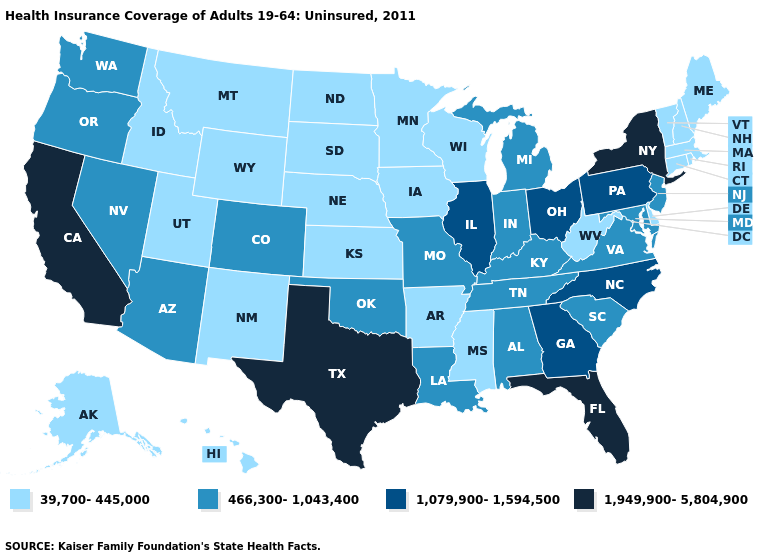What is the value of Oklahoma?
Concise answer only. 466,300-1,043,400. Which states have the highest value in the USA?
Write a very short answer. California, Florida, New York, Texas. What is the value of Washington?
Concise answer only. 466,300-1,043,400. Name the states that have a value in the range 39,700-445,000?
Short answer required. Alaska, Arkansas, Connecticut, Delaware, Hawaii, Idaho, Iowa, Kansas, Maine, Massachusetts, Minnesota, Mississippi, Montana, Nebraska, New Hampshire, New Mexico, North Dakota, Rhode Island, South Dakota, Utah, Vermont, West Virginia, Wisconsin, Wyoming. What is the highest value in states that border New Jersey?
Give a very brief answer. 1,949,900-5,804,900. Name the states that have a value in the range 1,079,900-1,594,500?
Quick response, please. Georgia, Illinois, North Carolina, Ohio, Pennsylvania. How many symbols are there in the legend?
Keep it brief. 4. Does Kansas have the same value as Virginia?
Be succinct. No. What is the value of New Mexico?
Concise answer only. 39,700-445,000. Name the states that have a value in the range 39,700-445,000?
Give a very brief answer. Alaska, Arkansas, Connecticut, Delaware, Hawaii, Idaho, Iowa, Kansas, Maine, Massachusetts, Minnesota, Mississippi, Montana, Nebraska, New Hampshire, New Mexico, North Dakota, Rhode Island, South Dakota, Utah, Vermont, West Virginia, Wisconsin, Wyoming. What is the value of Oregon?
Be succinct. 466,300-1,043,400. Does Montana have the lowest value in the USA?
Give a very brief answer. Yes. What is the highest value in states that border Michigan?
Be succinct. 1,079,900-1,594,500. Which states have the lowest value in the USA?
Be succinct. Alaska, Arkansas, Connecticut, Delaware, Hawaii, Idaho, Iowa, Kansas, Maine, Massachusetts, Minnesota, Mississippi, Montana, Nebraska, New Hampshire, New Mexico, North Dakota, Rhode Island, South Dakota, Utah, Vermont, West Virginia, Wisconsin, Wyoming. Which states have the lowest value in the Northeast?
Give a very brief answer. Connecticut, Maine, Massachusetts, New Hampshire, Rhode Island, Vermont. 